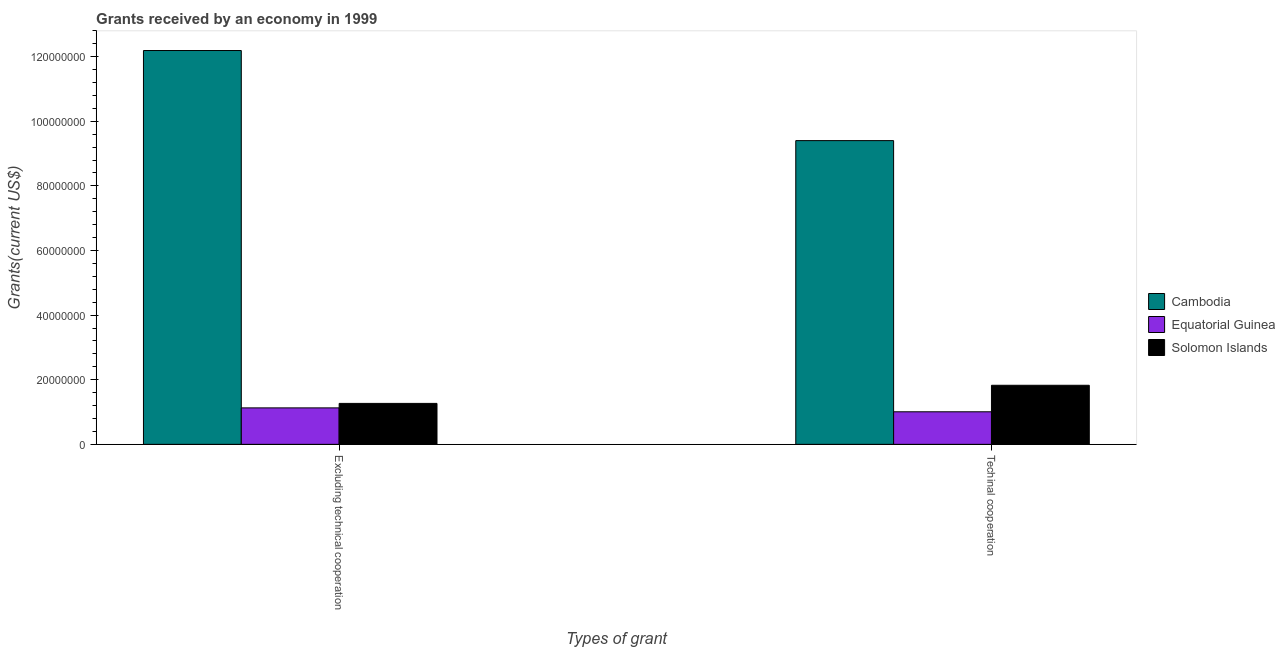How many different coloured bars are there?
Offer a very short reply. 3. Are the number of bars on each tick of the X-axis equal?
Your answer should be very brief. Yes. How many bars are there on the 1st tick from the right?
Make the answer very short. 3. What is the label of the 2nd group of bars from the left?
Ensure brevity in your answer.  Techinal cooperation. What is the amount of grants received(including technical cooperation) in Solomon Islands?
Keep it short and to the point. 1.83e+07. Across all countries, what is the maximum amount of grants received(including technical cooperation)?
Make the answer very short. 9.40e+07. Across all countries, what is the minimum amount of grants received(including technical cooperation)?
Offer a terse response. 1.01e+07. In which country was the amount of grants received(including technical cooperation) maximum?
Your answer should be compact. Cambodia. In which country was the amount of grants received(including technical cooperation) minimum?
Ensure brevity in your answer.  Equatorial Guinea. What is the total amount of grants received(including technical cooperation) in the graph?
Keep it short and to the point. 1.22e+08. What is the difference between the amount of grants received(including technical cooperation) in Equatorial Guinea and that in Cambodia?
Make the answer very short. -8.39e+07. What is the difference between the amount of grants received(excluding technical cooperation) in Equatorial Guinea and the amount of grants received(including technical cooperation) in Cambodia?
Ensure brevity in your answer.  -8.27e+07. What is the average amount of grants received(including technical cooperation) per country?
Offer a very short reply. 4.08e+07. What is the difference between the amount of grants received(excluding technical cooperation) and amount of grants received(including technical cooperation) in Solomon Islands?
Make the answer very short. -5.61e+06. In how many countries, is the amount of grants received(excluding technical cooperation) greater than 4000000 US$?
Give a very brief answer. 3. What is the ratio of the amount of grants received(including technical cooperation) in Cambodia to that in Equatorial Guinea?
Make the answer very short. 9.33. In how many countries, is the amount of grants received(excluding technical cooperation) greater than the average amount of grants received(excluding technical cooperation) taken over all countries?
Your response must be concise. 1. What does the 1st bar from the left in Excluding technical cooperation represents?
Keep it short and to the point. Cambodia. What does the 3rd bar from the right in Excluding technical cooperation represents?
Ensure brevity in your answer.  Cambodia. How many bars are there?
Keep it short and to the point. 6. Are all the bars in the graph horizontal?
Keep it short and to the point. No. Does the graph contain any zero values?
Offer a terse response. No. How many legend labels are there?
Your response must be concise. 3. What is the title of the graph?
Offer a terse response. Grants received by an economy in 1999. What is the label or title of the X-axis?
Offer a terse response. Types of grant. What is the label or title of the Y-axis?
Provide a short and direct response. Grants(current US$). What is the Grants(current US$) in Cambodia in Excluding technical cooperation?
Ensure brevity in your answer.  1.22e+08. What is the Grants(current US$) of Equatorial Guinea in Excluding technical cooperation?
Provide a short and direct response. 1.13e+07. What is the Grants(current US$) in Solomon Islands in Excluding technical cooperation?
Provide a succinct answer. 1.27e+07. What is the Grants(current US$) of Cambodia in Techinal cooperation?
Your response must be concise. 9.40e+07. What is the Grants(current US$) in Equatorial Guinea in Techinal cooperation?
Provide a short and direct response. 1.01e+07. What is the Grants(current US$) of Solomon Islands in Techinal cooperation?
Your response must be concise. 1.83e+07. Across all Types of grant, what is the maximum Grants(current US$) in Cambodia?
Give a very brief answer. 1.22e+08. Across all Types of grant, what is the maximum Grants(current US$) in Equatorial Guinea?
Make the answer very short. 1.13e+07. Across all Types of grant, what is the maximum Grants(current US$) of Solomon Islands?
Offer a very short reply. 1.83e+07. Across all Types of grant, what is the minimum Grants(current US$) in Cambodia?
Offer a very short reply. 9.40e+07. Across all Types of grant, what is the minimum Grants(current US$) in Equatorial Guinea?
Make the answer very short. 1.01e+07. Across all Types of grant, what is the minimum Grants(current US$) of Solomon Islands?
Offer a terse response. 1.27e+07. What is the total Grants(current US$) in Cambodia in the graph?
Keep it short and to the point. 2.16e+08. What is the total Grants(current US$) in Equatorial Guinea in the graph?
Make the answer very short. 2.14e+07. What is the total Grants(current US$) of Solomon Islands in the graph?
Keep it short and to the point. 3.10e+07. What is the difference between the Grants(current US$) in Cambodia in Excluding technical cooperation and that in Techinal cooperation?
Provide a succinct answer. 2.79e+07. What is the difference between the Grants(current US$) in Equatorial Guinea in Excluding technical cooperation and that in Techinal cooperation?
Provide a short and direct response. 1.21e+06. What is the difference between the Grants(current US$) in Solomon Islands in Excluding technical cooperation and that in Techinal cooperation?
Offer a terse response. -5.61e+06. What is the difference between the Grants(current US$) of Cambodia in Excluding technical cooperation and the Grants(current US$) of Equatorial Guinea in Techinal cooperation?
Ensure brevity in your answer.  1.12e+08. What is the difference between the Grants(current US$) in Cambodia in Excluding technical cooperation and the Grants(current US$) in Solomon Islands in Techinal cooperation?
Provide a short and direct response. 1.04e+08. What is the difference between the Grants(current US$) of Equatorial Guinea in Excluding technical cooperation and the Grants(current US$) of Solomon Islands in Techinal cooperation?
Give a very brief answer. -7.00e+06. What is the average Grants(current US$) of Cambodia per Types of grant?
Ensure brevity in your answer.  1.08e+08. What is the average Grants(current US$) in Equatorial Guinea per Types of grant?
Offer a very short reply. 1.07e+07. What is the average Grants(current US$) in Solomon Islands per Types of grant?
Ensure brevity in your answer.  1.55e+07. What is the difference between the Grants(current US$) of Cambodia and Grants(current US$) of Equatorial Guinea in Excluding technical cooperation?
Your answer should be compact. 1.11e+08. What is the difference between the Grants(current US$) of Cambodia and Grants(current US$) of Solomon Islands in Excluding technical cooperation?
Give a very brief answer. 1.09e+08. What is the difference between the Grants(current US$) in Equatorial Guinea and Grants(current US$) in Solomon Islands in Excluding technical cooperation?
Keep it short and to the point. -1.39e+06. What is the difference between the Grants(current US$) of Cambodia and Grants(current US$) of Equatorial Guinea in Techinal cooperation?
Your answer should be compact. 8.39e+07. What is the difference between the Grants(current US$) of Cambodia and Grants(current US$) of Solomon Islands in Techinal cooperation?
Make the answer very short. 7.57e+07. What is the difference between the Grants(current US$) of Equatorial Guinea and Grants(current US$) of Solomon Islands in Techinal cooperation?
Your answer should be compact. -8.21e+06. What is the ratio of the Grants(current US$) of Cambodia in Excluding technical cooperation to that in Techinal cooperation?
Offer a very short reply. 1.3. What is the ratio of the Grants(current US$) in Equatorial Guinea in Excluding technical cooperation to that in Techinal cooperation?
Your response must be concise. 1.12. What is the ratio of the Grants(current US$) in Solomon Islands in Excluding technical cooperation to that in Techinal cooperation?
Ensure brevity in your answer.  0.69. What is the difference between the highest and the second highest Grants(current US$) in Cambodia?
Provide a short and direct response. 2.79e+07. What is the difference between the highest and the second highest Grants(current US$) of Equatorial Guinea?
Offer a very short reply. 1.21e+06. What is the difference between the highest and the second highest Grants(current US$) of Solomon Islands?
Your response must be concise. 5.61e+06. What is the difference between the highest and the lowest Grants(current US$) in Cambodia?
Give a very brief answer. 2.79e+07. What is the difference between the highest and the lowest Grants(current US$) in Equatorial Guinea?
Offer a very short reply. 1.21e+06. What is the difference between the highest and the lowest Grants(current US$) in Solomon Islands?
Your answer should be compact. 5.61e+06. 